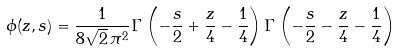Convert formula to latex. <formula><loc_0><loc_0><loc_500><loc_500>\phi ( z , s ) = \frac { 1 } { 8 \sqrt { 2 } \, \pi ^ { 2 } } \Gamma \left ( - \frac { s } { 2 } + \frac { z } { 4 } - \frac { 1 } { 4 } \right ) \Gamma \left ( - \frac { s } { 2 } - \frac { z } { 4 } - \frac { 1 } { 4 } \right )</formula> 